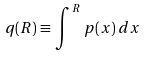Convert formula to latex. <formula><loc_0><loc_0><loc_500><loc_500>q ( R ) \equiv \, \int ^ { R } \, p ( x ) \, d x</formula> 